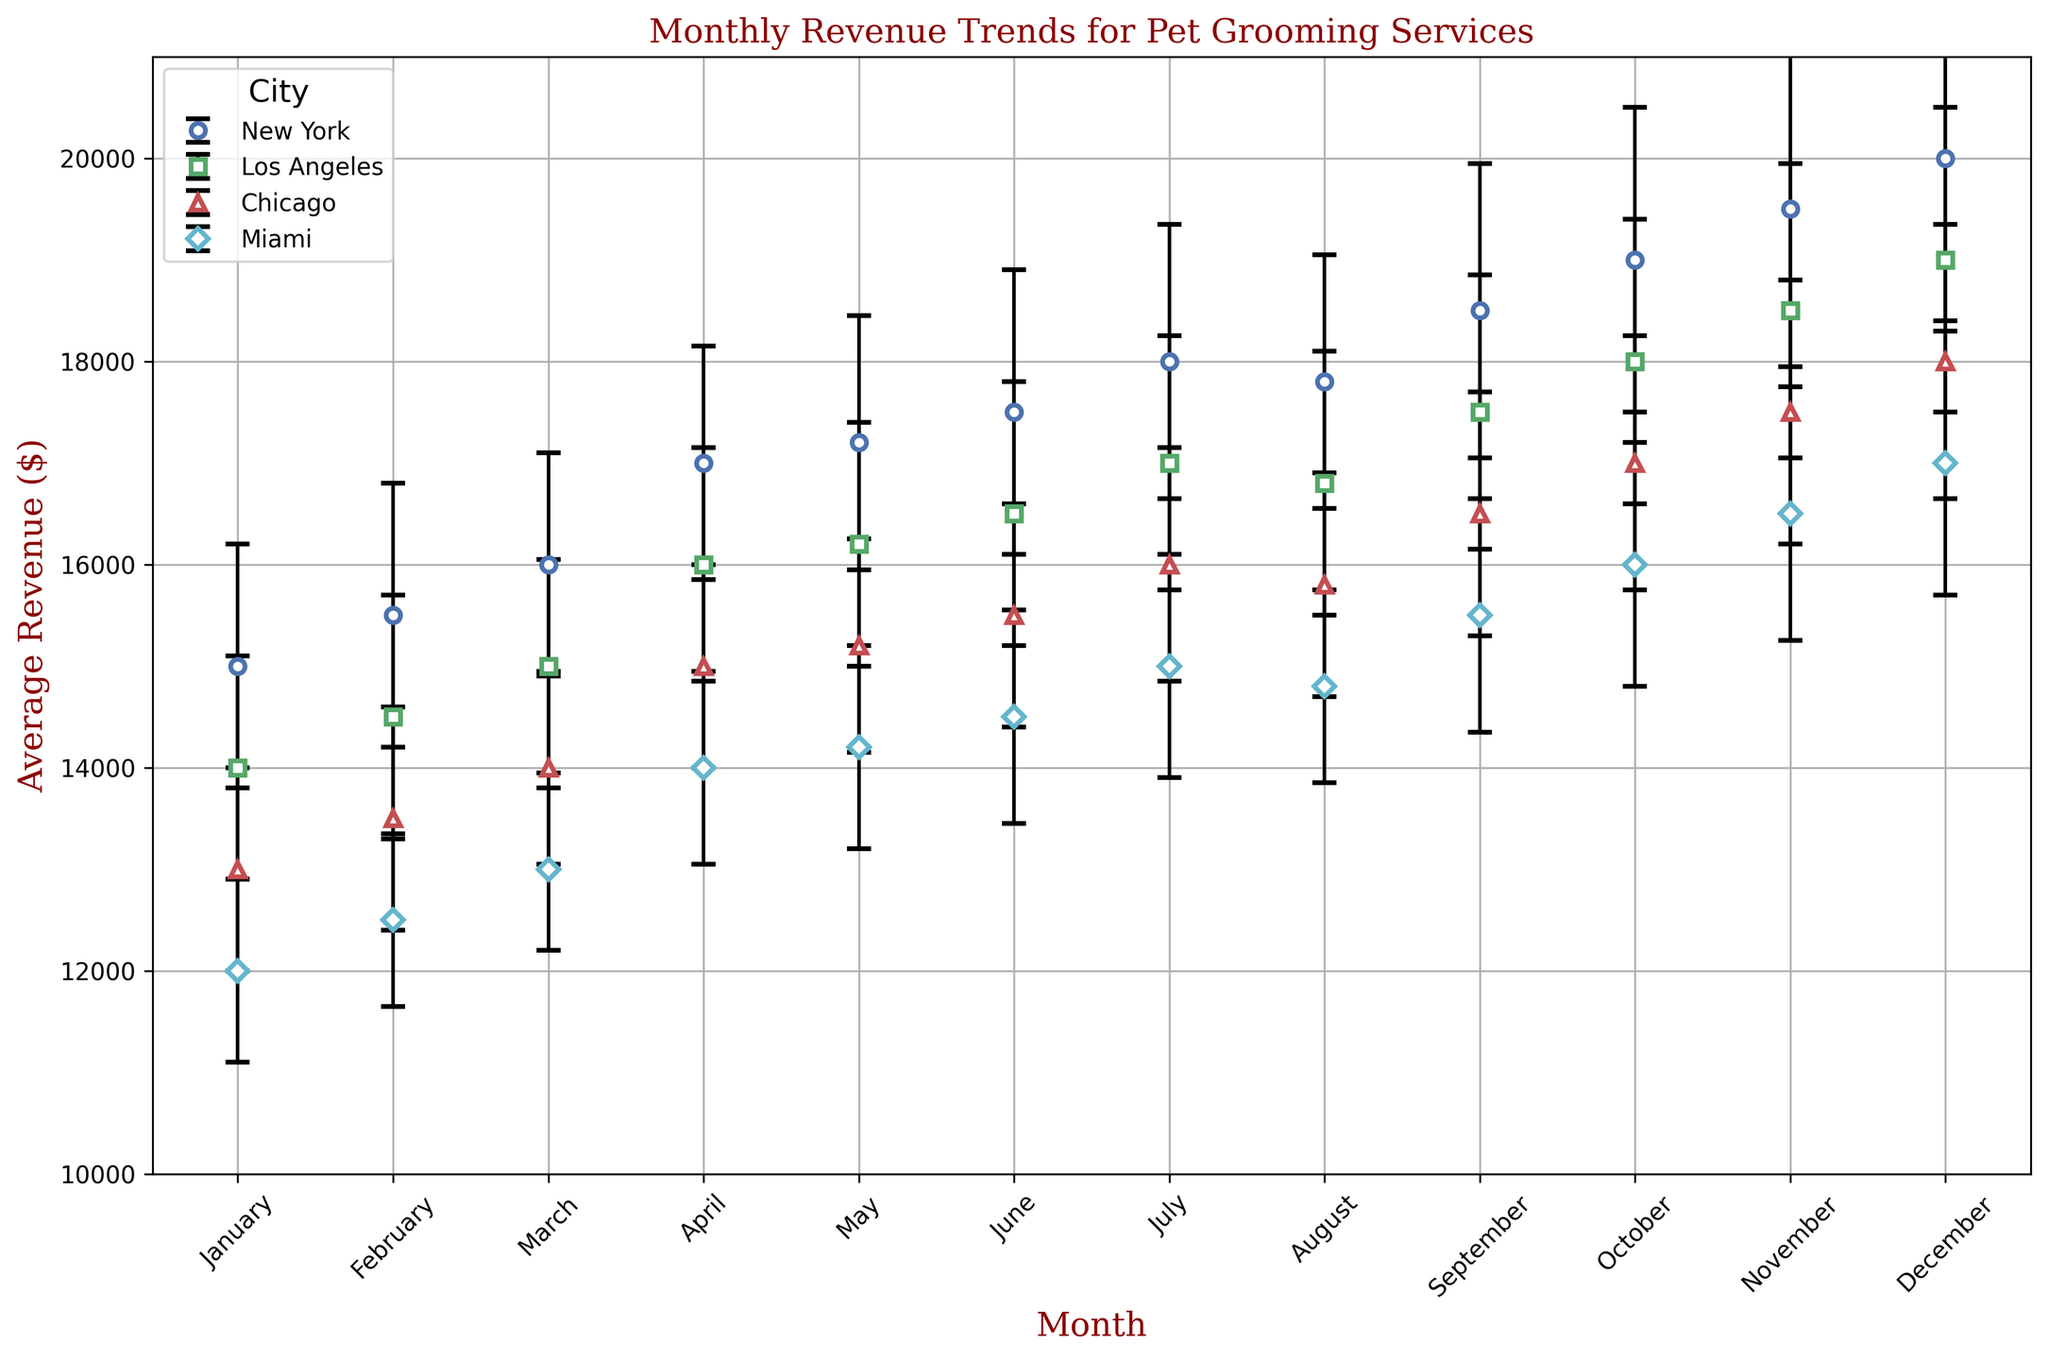Which city has the highest average revenue in December? Look at the December data points for each city and compare their average revenues. New York has the highest average revenue in December at $20,000.
Answer: New York Which city has the lowest average revenue in January? Examine the January data points for each city and compare their average revenues. Miami has the lowest average revenue in January at $12,000.
Answer: Miami What is the approximate average revenue of Los Angeles in July? Identify the data point for Los Angeles in July, which shows the average revenue. The average revenue for Los Angeles in July is $17,000.
Answer: $17,000 During which month does New York show the highest standard deviation in revenue? Review the standard deviation values for each month in New York. December shows the highest standard deviation at $1,600.
Answer: December Between Miami and Chicago, which city has higher average revenue in April? Compare the average revenue for Miami and Chicago in April. Chicago's average revenue is $15,000, whereas Miami's is $14,000. Therefore, Chicago has a higher average revenue.
Answer: Chicago In terms of average revenue, how does Los Angeles in September compare to New York in the same month? Examine the average revenues for Los Angeles and New York in September. Los Angeles has $17,500, while New York has $18,500. Therefore, New York's average revenue is higher.
Answer: New York Which city shows the least variation in revenue during February? Check the standard deviation values for February across all cities and identify the smallest value. Miami has the smallest standard deviation in February at $850.
Answer: Miami By how much does the average revenue for Chicago in October exceed that of Miami in the same month? Calculate the difference between the average revenues of Chicago and Miami in October. Chicago's revenue is $17,000 and Miami's is $16,000. So, the difference is $1,000.
Answer: $1,000 What is the trend in average revenue for New York from January to December? Observe the pattern of New York's average revenue from January to December. The average revenue increases steadily from $15,000 in January to $20,000 in December.
Answer: Increasing steadily 